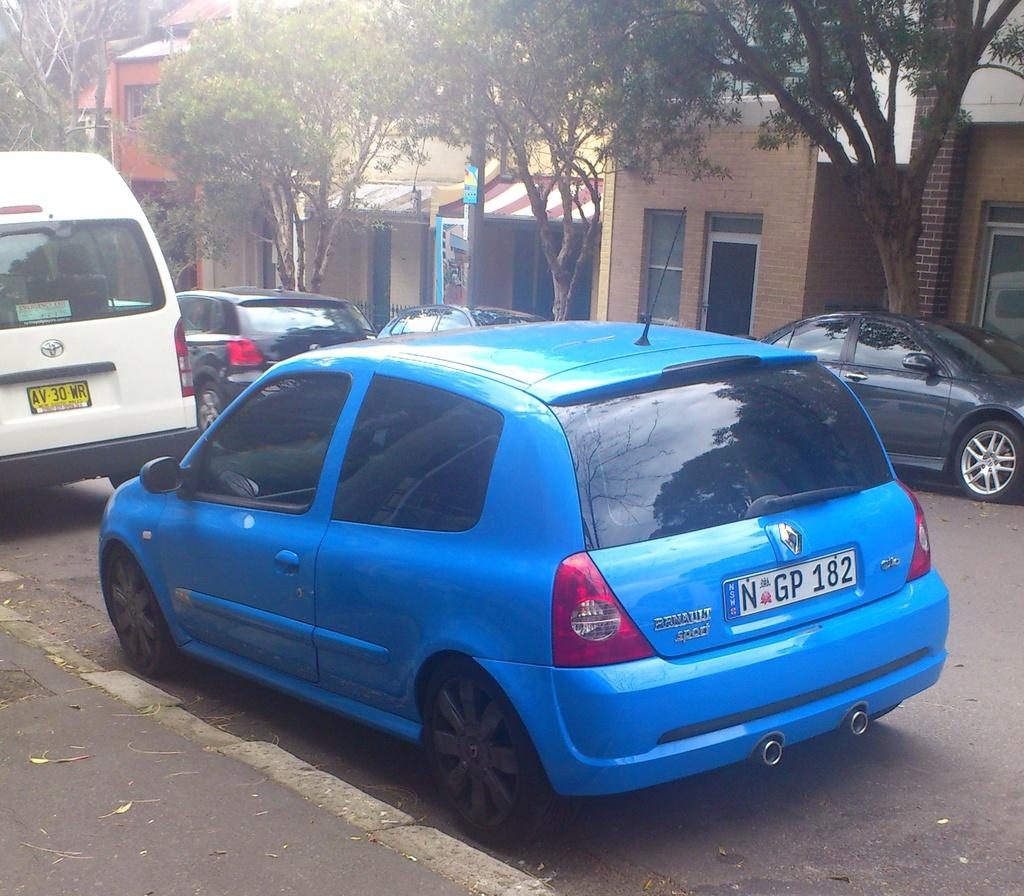What is happening on the road in the image? There are vehicles on the road in the image. What can be seen in the distance behind the vehicles? There are buildings and trees in the background of the image. What type of spark can be seen coming from the buildings in the image? There is no spark visible in the image; the buildings are not on fire or emitting any sparks. 